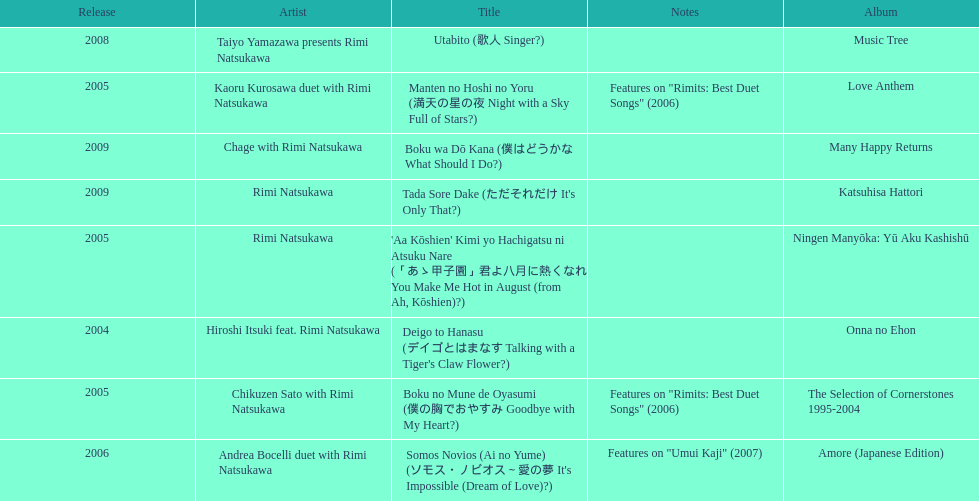What year was the first title released? 2004. 